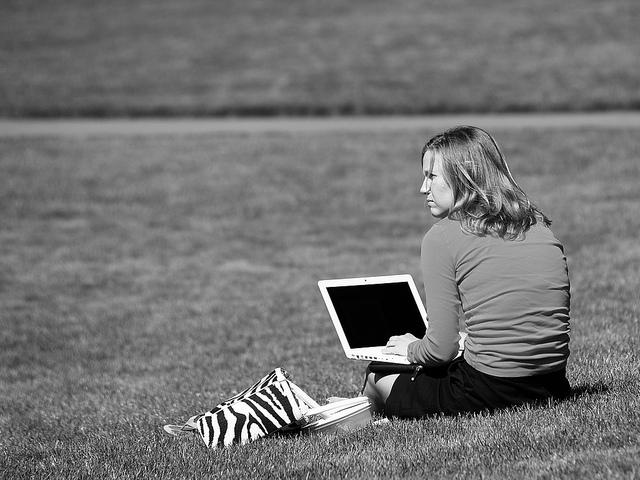What pattern is on the bag?
Be succinct. Zebra. Is this a current era photo?
Answer briefly. Yes. Are they indoors?
Concise answer only. No. 